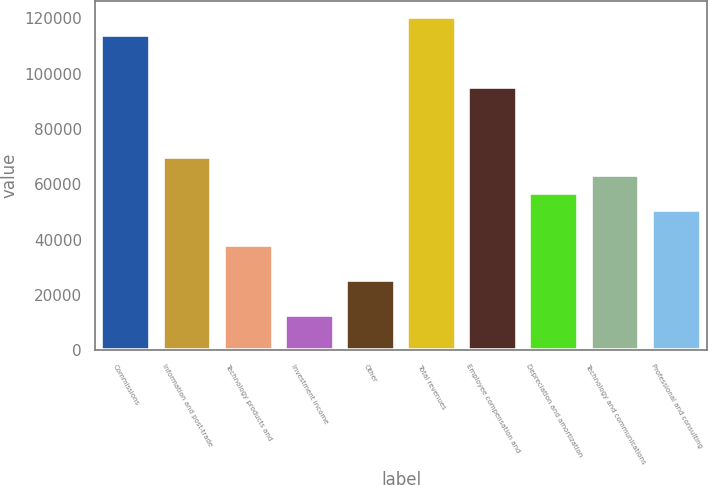<chart> <loc_0><loc_0><loc_500><loc_500><bar_chart><fcel>Commissions<fcel>Information and post-trade<fcel>Technology products and<fcel>Investment income<fcel>Other<fcel>Total revenues<fcel>Employee compensation and<fcel>Depreciation and amortization<fcel>Technology and communications<fcel>Professional and consulting<nl><fcel>114116<fcel>69737.7<fcel>38039<fcel>12680<fcel>25359.5<fcel>120456<fcel>95096.7<fcel>57058.2<fcel>63398<fcel>50718.5<nl></chart> 